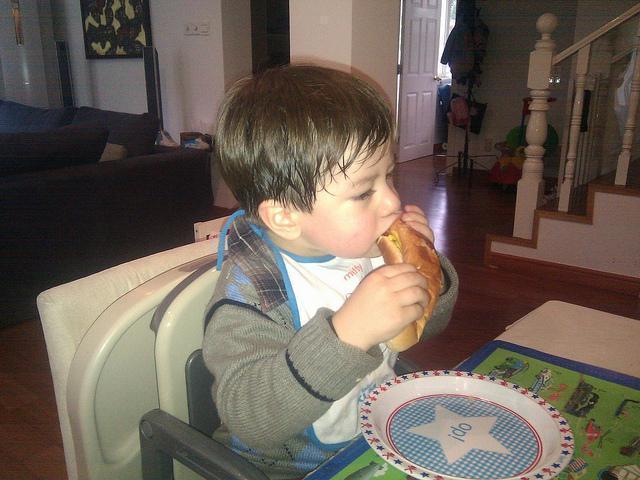What color is the plaid pattern around the star on top of the plate?
Choose the correct response, then elucidate: 'Answer: answer
Rationale: rationale.'
Options: Blue, green, red, purple. Answer: blue.
Rationale: The color is blue. 